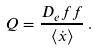Convert formula to latex. <formula><loc_0><loc_0><loc_500><loc_500>Q = \frac { D _ { e } f f } { \langle \dot { x } \rangle } \, .</formula> 